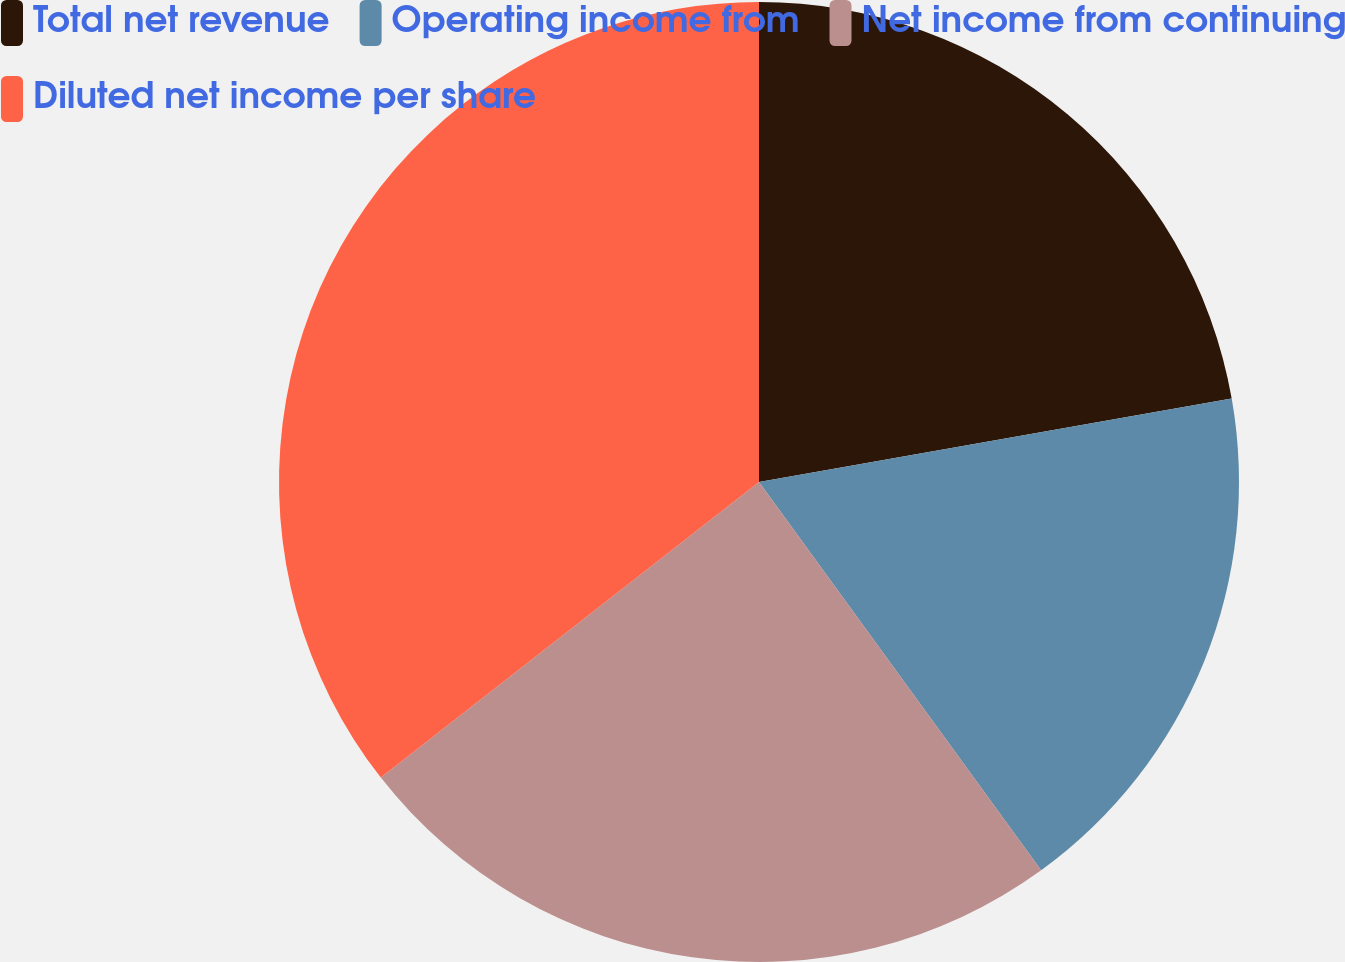Convert chart. <chart><loc_0><loc_0><loc_500><loc_500><pie_chart><fcel>Total net revenue<fcel>Operating income from<fcel>Net income from continuing<fcel>Diluted net income per share<nl><fcel>22.22%<fcel>17.78%<fcel>24.44%<fcel>35.56%<nl></chart> 